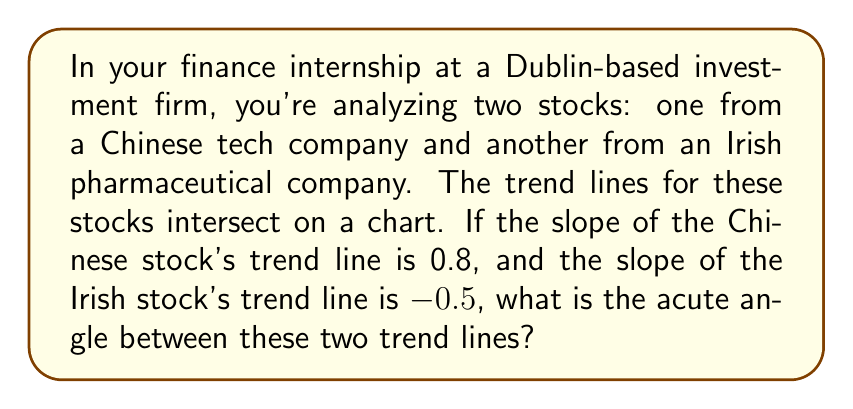Show me your answer to this math problem. Let's approach this step-by-step:

1) The angle between two lines can be calculated using the formula:

   $$\tan \theta = \left|\frac{m_1 - m_2}{1 + m_1m_2}\right|$$

   where $m_1$ and $m_2$ are the slopes of the two lines, and $\theta$ is the angle between them.

2) We're given:
   $m_1 = 0.8$ (slope of Chinese stock's trend line)
   $m_2 = -0.5$ (slope of Irish stock's trend line)

3) Let's substitute these values into the formula:

   $$\tan \theta = \left|\frac{0.8 - (-0.5)}{1 + (0.8)(-0.5)}\right|$$

4) Simplify the numerator and denominator:

   $$\tan \theta = \left|\frac{1.3}{1 - 0.4}\right| = \left|\frac{1.3}{0.6}\right|$$

5) Calculate:

   $$\tan \theta = 2.1666...$$

6) To find $\theta$, we need to take the inverse tangent (arctan or $\tan^{-1}$):

   $$\theta = \tan^{-1}(2.1666...)$$

7) Using a calculator or computer:

   $$\theta \approx 65.2^\circ$$

This is the acute angle between the two trend lines.
Answer: $65.2^\circ$ 